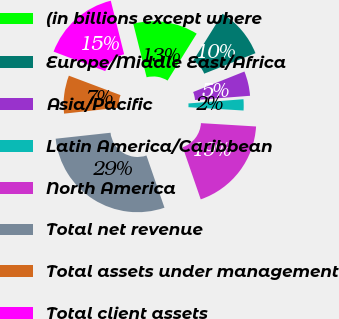<chart> <loc_0><loc_0><loc_500><loc_500><pie_chart><fcel>(in billions except where<fcel>Europe/Middle East/Africa<fcel>Asia/Pacific<fcel>Latin America/Caribbean<fcel>North America<fcel>Total net revenue<fcel>Total assets under management<fcel>Total client assets<nl><fcel>12.74%<fcel>10.1%<fcel>4.83%<fcel>2.19%<fcel>18.74%<fcel>28.57%<fcel>7.46%<fcel>15.38%<nl></chart> 